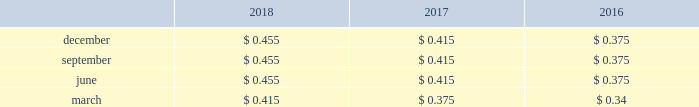Flows of the company 2019s subsidiaries , the receipt of dividends and repayments of indebtedness from the company 2019s subsidiaries , compliance with delaware corporate and other laws , compliance with the contractual provisions of debt and other agreements , and other factors .
The company 2019s dividend rate on its common stock is determined by the board of directors on a quarterly basis and takes into consideration , among other factors , current and possible future developments that may affect the company 2019s income and cash flows .
When dividends on common stock are declared , they are typically paid in march , june , september and december .
Historically , dividends have been paid quarterly to holders of record less than 30 days prior to the distribution date .
Since the dividends on the company 2019s common stock are not cumulative , only declared dividends are paid .
During 2018 , 2017 and 2016 , the company paid $ 319 million , $ 289 million and $ 261 million in cash dividends , respectively .
The table provides the per share cash dividends paid for the years ended december 31: .
On december 7 , 2018 , the company 2019s board of directors declared a quarterly cash dividend payment of $ 0.455 per share payable on march 1 , 2019 , to shareholders of record as of february 7 , 2019 .
Equity forward transaction see note 4 2014acquisitions and divestitures for information regarding the forward sale agreements entered into by the company on april 11 , 2018 , and the subsequent settlement of these agreements on june 7 , 2018 .
Regulatory restrictions the issuance of long-term debt or equity securities by the company or american water capital corp .
( 201cawcc 201d ) , the company 2019s wholly owned financing subsidiary , does not require authorization of any state puc if no guarantee or pledge of the regulated subsidiaries is utilized .
However , state puc authorization is required to issue long-term debt at most of the company 2019s regulated subsidiaries .
The company 2019s regulated subsidiaries normally obtain the required approvals on a periodic basis to cover their anticipated financing needs for a period of time or in connection with a specific financing .
Under applicable law , the company 2019s subsidiaries can pay dividends only from retained , undistributed or current earnings .
A significant loss recorded at a subsidiary may limit the dividends that the subsidiary can distribute to american water .
Furthermore , the ability of the company 2019s subsidiaries to pay upstream dividends or repay indebtedness to american water is subject to compliance with applicable regulatory restrictions and financial obligations , including , for example , debt service and preferred and preference stock dividends , as well as applicable corporate , tax and other laws and regulations , and other agreements or covenants made or entered into by the company and its subsidiaries .
Note 10 : stock based compensation the company has granted stock options , stock units and dividend equivalents to non-employee directors , officers and other key employees of the company pursuant to the terms of its 2007 omnibus equity compensation plan ( the 201c2007 plan 201d ) .
Stock units under the 2007 plan generally vest based on ( i ) continued employment with the company ( 201crsus 201d ) , or ( ii ) continued employment with the company where distribution of the shares is subject to the satisfaction in whole or in part of stated performance-based goals ( 201cpsus 201d ) .
The total aggregate number of shares of common stock that may be issued under the 2007 plan is 15.5 million .
As of .
During 2018 , 2017 and 2016 , what did the company pay ( millions ) in cash dividends? 
Computations: ((319 + 289) + 261)
Answer: 869.0. 